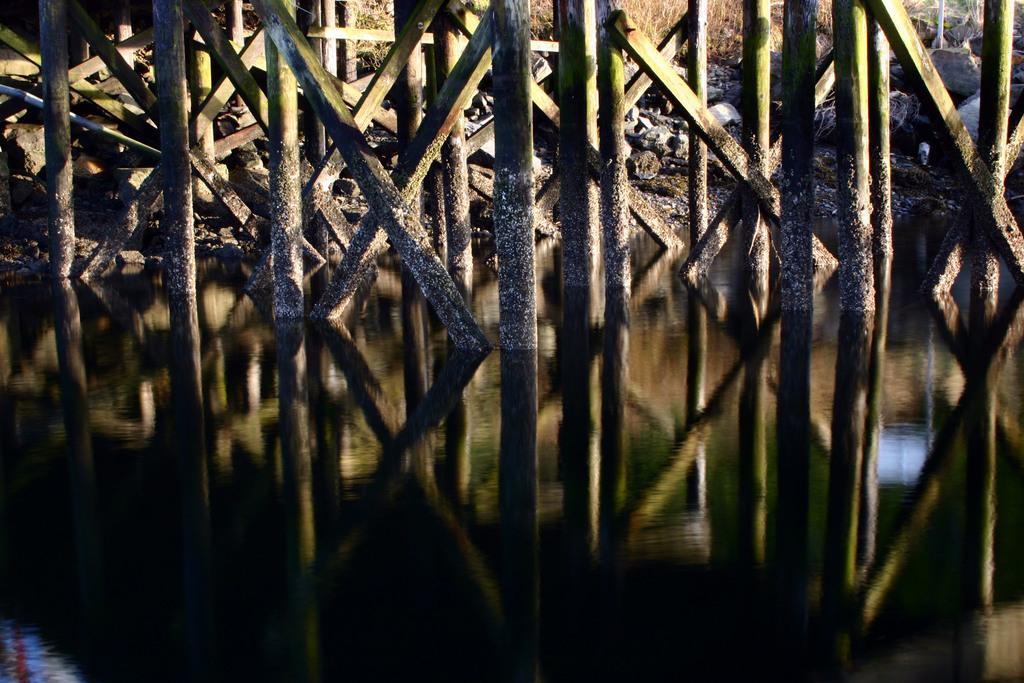What is the primary element present in the picture? There is water in the picture. What type of structures can be seen in the picture? There are wooden poles in the picture. What natural elements are visible in the picture? There are rocks in the picture. How many cacti can be seen growing on the hill in the picture? There are no cacti or hills present in the image; it only features water, wooden poles, and rocks. 